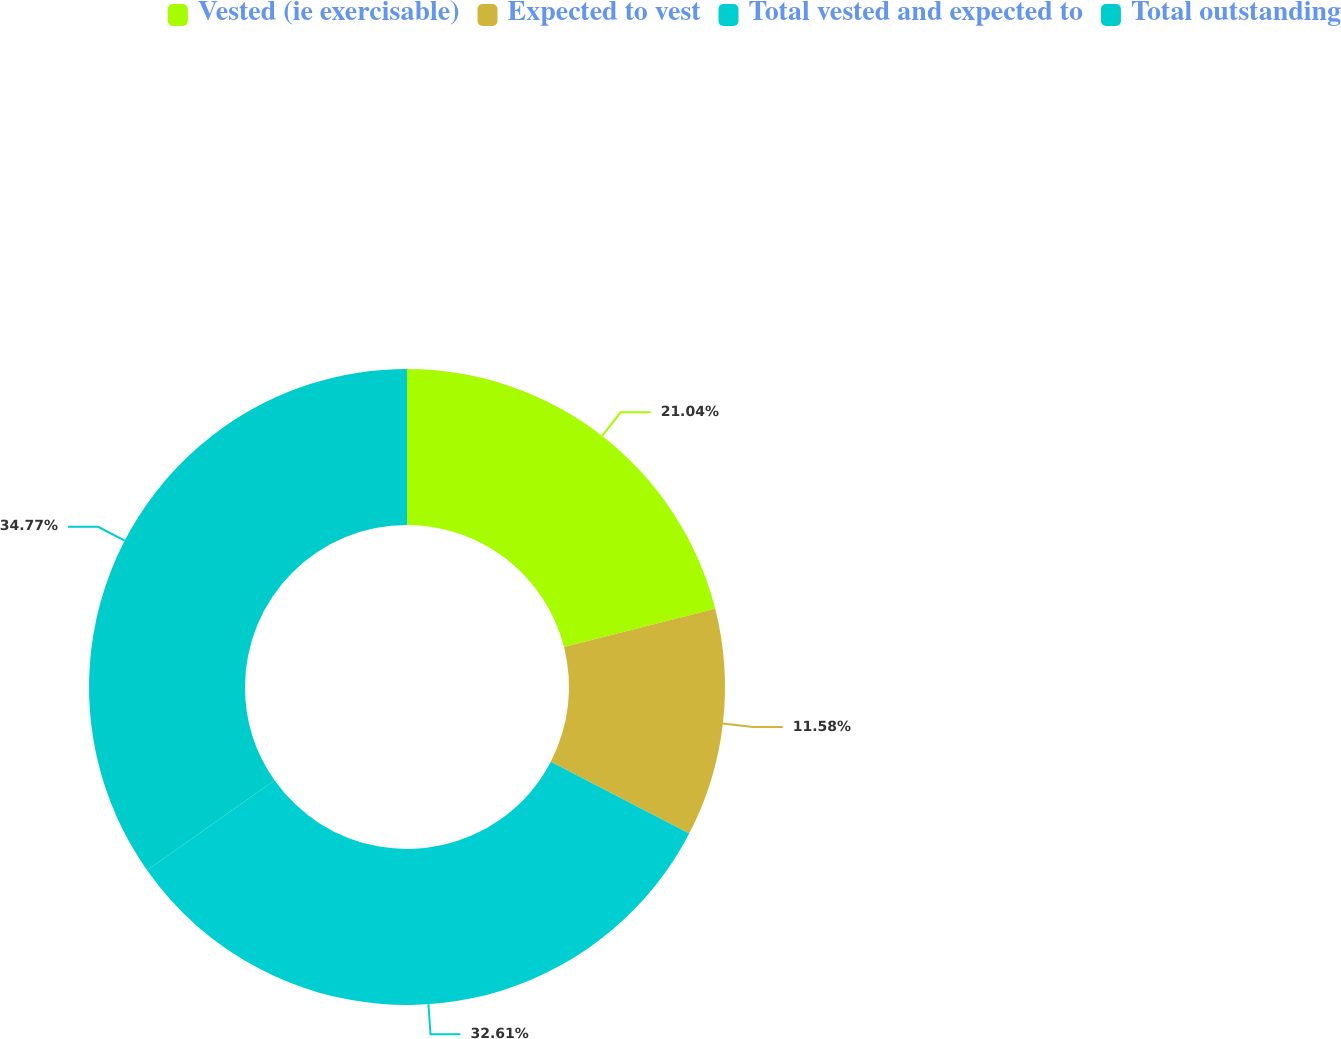Convert chart. <chart><loc_0><loc_0><loc_500><loc_500><pie_chart><fcel>Vested (ie exercisable)<fcel>Expected to vest<fcel>Total vested and expected to<fcel>Total outstanding<nl><fcel>21.04%<fcel>11.58%<fcel>32.61%<fcel>34.77%<nl></chart> 